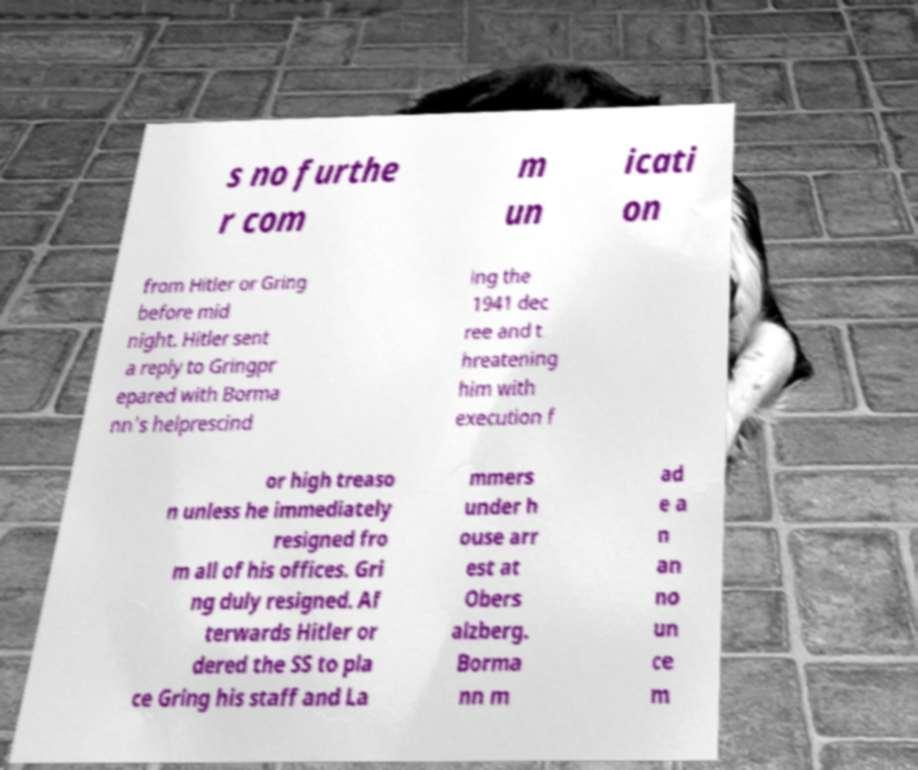Please read and relay the text visible in this image. What does it say? s no furthe r com m un icati on from Hitler or Gring before mid night. Hitler sent a reply to Gringpr epared with Borma nn's helprescind ing the 1941 dec ree and t hreatening him with execution f or high treaso n unless he immediately resigned fro m all of his offices. Gri ng duly resigned. Af terwards Hitler or dered the SS to pla ce Gring his staff and La mmers under h ouse arr est at Obers alzberg. Borma nn m ad e a n an no un ce m 